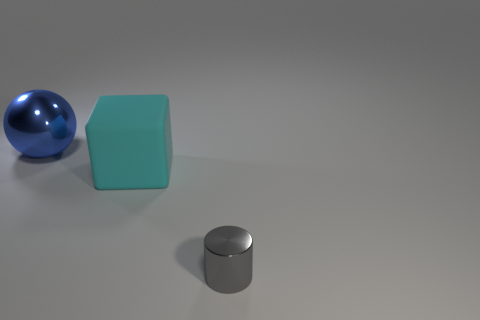Add 1 tiny gray metallic objects. How many objects exist? 4 Subtract all cubes. How many objects are left? 2 Add 3 tiny gray metal cylinders. How many tiny gray metal cylinders are left? 4 Add 1 rubber cubes. How many rubber cubes exist? 2 Subtract 0 brown cubes. How many objects are left? 3 Subtract all big green matte cylinders. Subtract all small objects. How many objects are left? 2 